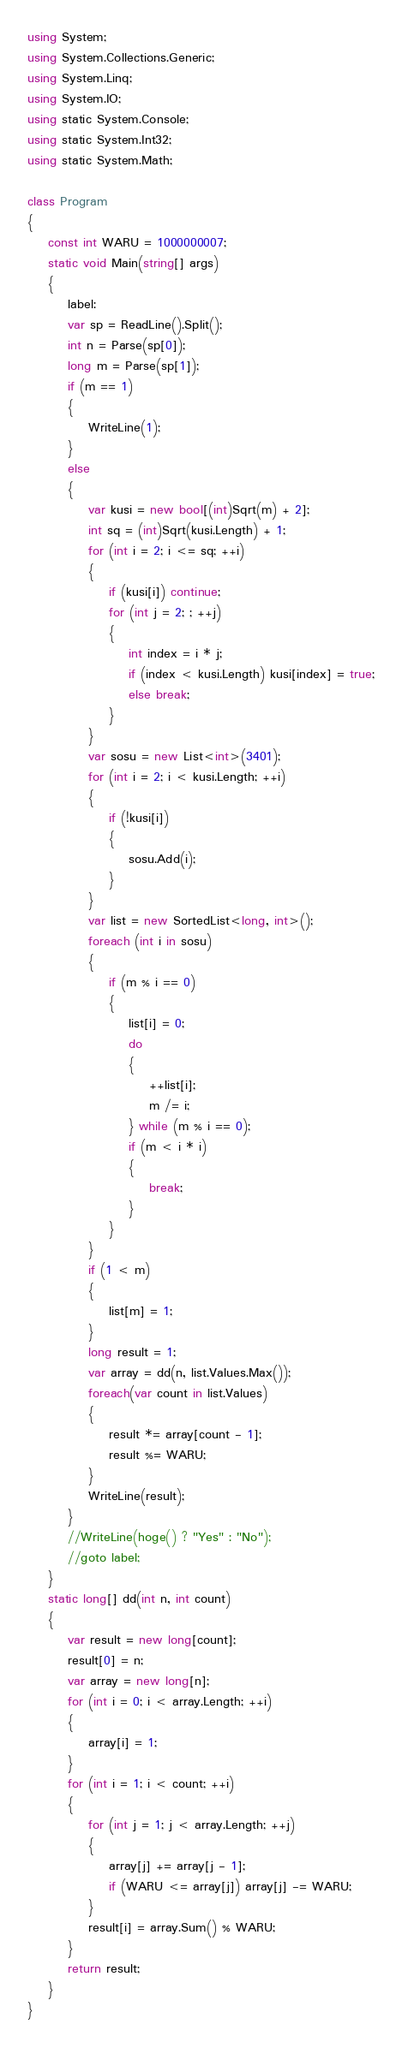<code> <loc_0><loc_0><loc_500><loc_500><_C#_>using System;
using System.Collections.Generic;
using System.Linq;
using System.IO;
using static System.Console;
using static System.Int32;
using static System.Math;

class Program
{
    const int WARU = 1000000007;
    static void Main(string[] args)
    {
        label:
        var sp = ReadLine().Split();
        int n = Parse(sp[0]);
        long m = Parse(sp[1]);
        if (m == 1)
        {
            WriteLine(1);
        }
        else
        {
            var kusi = new bool[(int)Sqrt(m) + 2];
            int sq = (int)Sqrt(kusi.Length) + 1;
            for (int i = 2; i <= sq; ++i)
            {
                if (kusi[i]) continue;
                for (int j = 2; ; ++j)
                {
                    int index = i * j;
                    if (index < kusi.Length) kusi[index] = true;
                    else break;
                }
            }
            var sosu = new List<int>(3401);
            for (int i = 2; i < kusi.Length; ++i)
            {
                if (!kusi[i])
                {
                    sosu.Add(i);
                }
            }
            var list = new SortedList<long, int>();
            foreach (int i in sosu)
            {
                if (m % i == 0)
                {
                    list[i] = 0;
                    do
                    {
                        ++list[i];
                        m /= i;
                    } while (m % i == 0);
                    if (m < i * i)
                    {
                        break;
                    }
                }
            }
            if (1 < m)
            {
                list[m] = 1;
            }
            long result = 1;
            var array = dd(n, list.Values.Max());
            foreach(var count in list.Values)
            {
                result *= array[count - 1];
                result %= WARU;
            }
            WriteLine(result);
        }
        //WriteLine(hoge() ? "Yes" : "No");
        //goto label;
    }
    static long[] dd(int n, int count)
    {
        var result = new long[count];
        result[0] = n;
        var array = new long[n];
        for (int i = 0; i < array.Length; ++i)
        {
            array[i] = 1;
        }
        for (int i = 1; i < count; ++i)
        {
            for (int j = 1; j < array.Length; ++j)
            {
                array[j] += array[j - 1];
                if (WARU <= array[j]) array[j] -= WARU;
            }
            result[i] = array.Sum() % WARU;
        }
        return result;
    }
}
</code> 